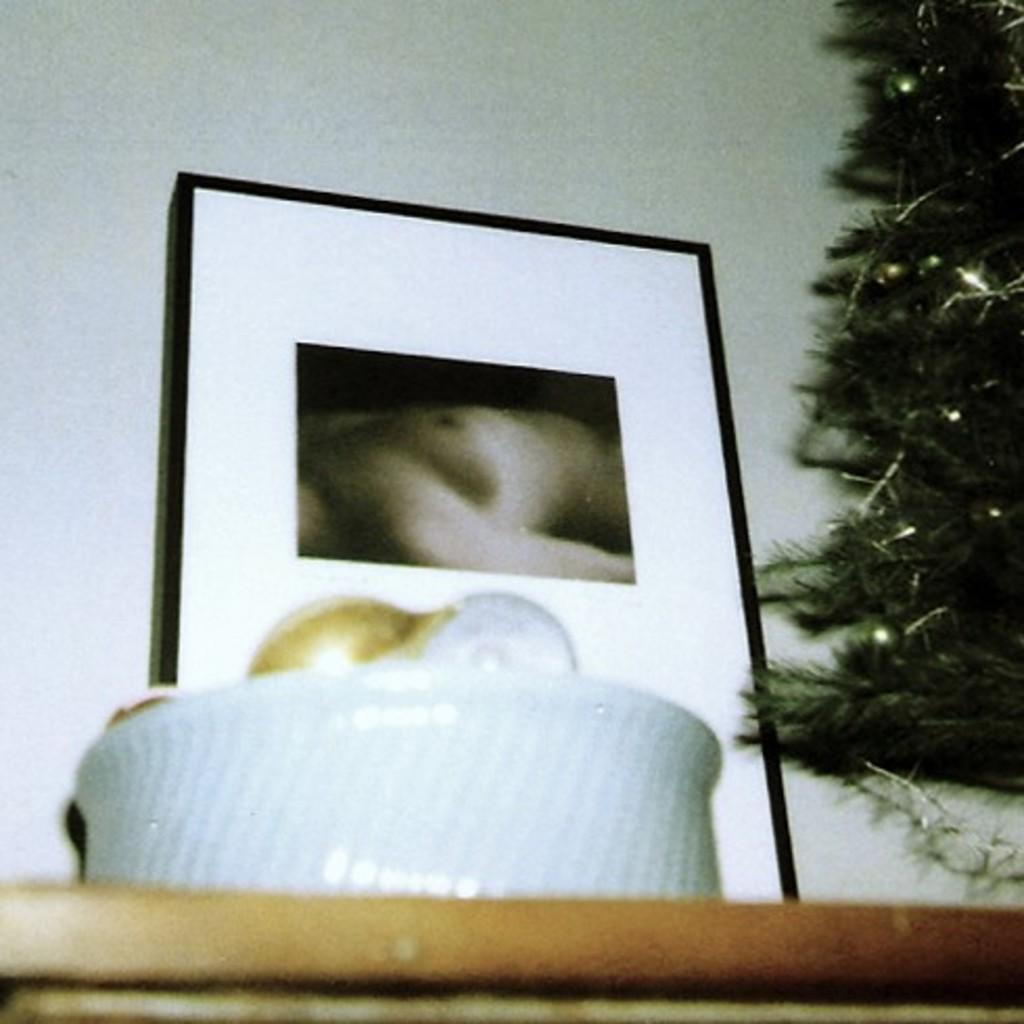How would you summarize this image in a sentence or two? In the foreground of the image we can see a bowl placed on the table. To the right side of the image we can see a tree. In the background, we can see a photo frame. 